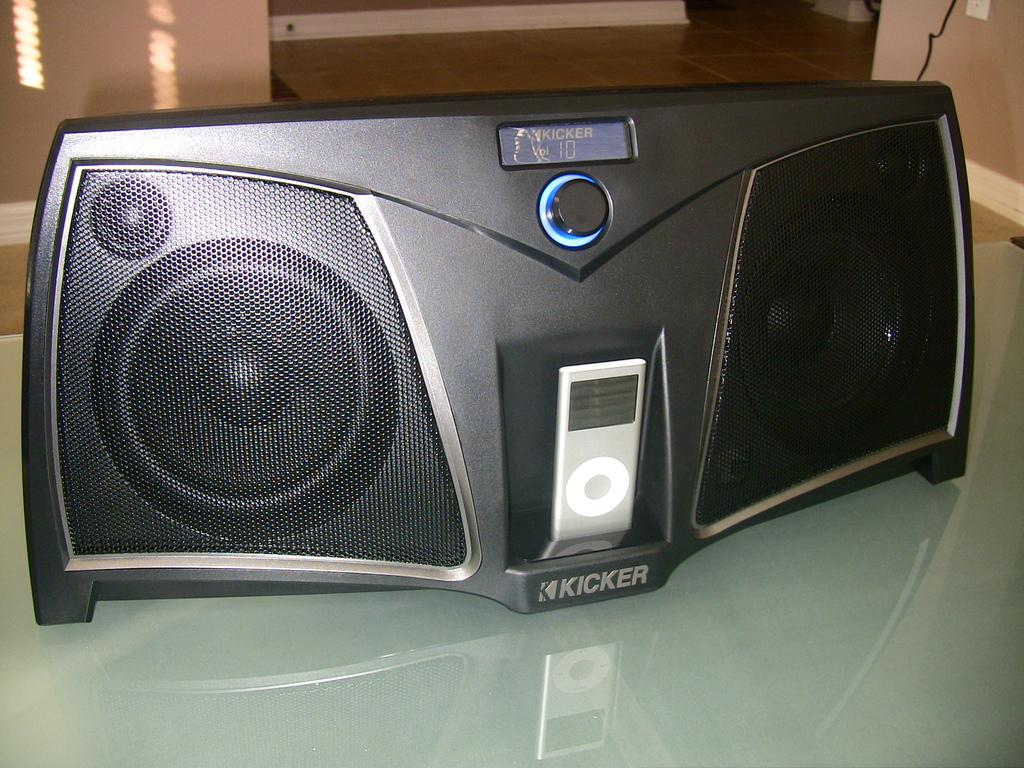What is the color of the speaker in the image? The speaker in the image is black. What is the speaker placed on? The speaker is kept on a glass table. What can be seen in the background of the image? There is a wall and the floor visible in the background of the image. What type of brass instrument is being played in the image? There is no brass instrument or any indication of music being played in the image; it only features a black color speaker on a glass table. 